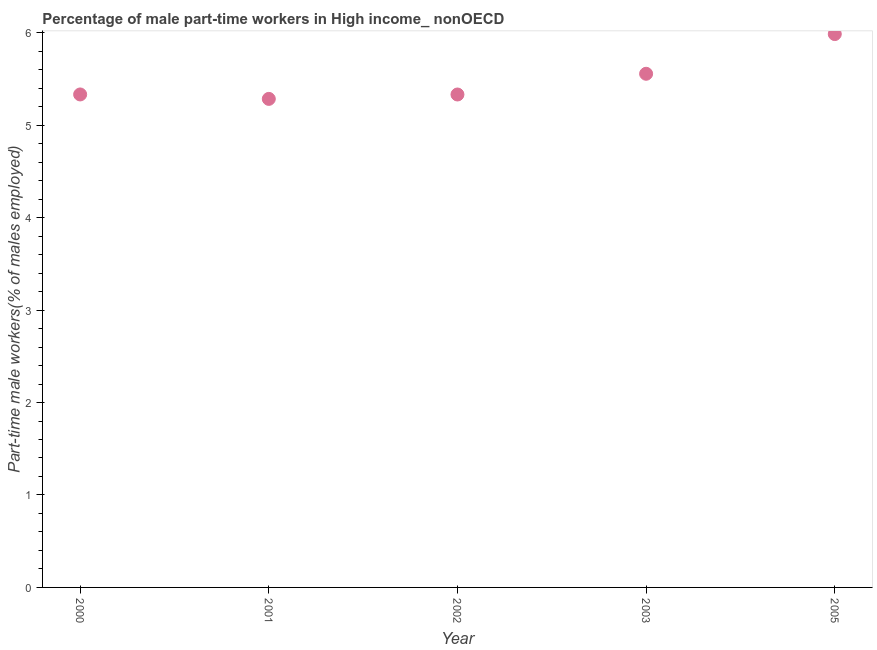What is the percentage of part-time male workers in 2005?
Give a very brief answer. 5.98. Across all years, what is the maximum percentage of part-time male workers?
Offer a very short reply. 5.98. Across all years, what is the minimum percentage of part-time male workers?
Your response must be concise. 5.28. In which year was the percentage of part-time male workers maximum?
Your answer should be very brief. 2005. What is the sum of the percentage of part-time male workers?
Provide a succinct answer. 27.49. What is the difference between the percentage of part-time male workers in 2002 and 2003?
Offer a terse response. -0.22. What is the average percentage of part-time male workers per year?
Ensure brevity in your answer.  5.5. What is the median percentage of part-time male workers?
Your response must be concise. 5.33. Do a majority of the years between 2000 and 2002 (inclusive) have percentage of part-time male workers greater than 1.8 %?
Keep it short and to the point. Yes. What is the ratio of the percentage of part-time male workers in 2000 to that in 2002?
Keep it short and to the point. 1. Is the percentage of part-time male workers in 2000 less than that in 2005?
Offer a terse response. Yes. What is the difference between the highest and the second highest percentage of part-time male workers?
Offer a terse response. 0.43. What is the difference between the highest and the lowest percentage of part-time male workers?
Your answer should be very brief. 0.7. Does the percentage of part-time male workers monotonically increase over the years?
Keep it short and to the point. No. How many years are there in the graph?
Offer a very short reply. 5. Does the graph contain grids?
Offer a terse response. No. What is the title of the graph?
Provide a succinct answer. Percentage of male part-time workers in High income_ nonOECD. What is the label or title of the Y-axis?
Give a very brief answer. Part-time male workers(% of males employed). What is the Part-time male workers(% of males employed) in 2000?
Provide a short and direct response. 5.33. What is the Part-time male workers(% of males employed) in 2001?
Provide a short and direct response. 5.28. What is the Part-time male workers(% of males employed) in 2002?
Offer a terse response. 5.33. What is the Part-time male workers(% of males employed) in 2003?
Provide a succinct answer. 5.56. What is the Part-time male workers(% of males employed) in 2005?
Ensure brevity in your answer.  5.98. What is the difference between the Part-time male workers(% of males employed) in 2000 and 2001?
Ensure brevity in your answer.  0.05. What is the difference between the Part-time male workers(% of males employed) in 2000 and 2002?
Provide a short and direct response. 0. What is the difference between the Part-time male workers(% of males employed) in 2000 and 2003?
Provide a succinct answer. -0.22. What is the difference between the Part-time male workers(% of males employed) in 2000 and 2005?
Offer a terse response. -0.65. What is the difference between the Part-time male workers(% of males employed) in 2001 and 2002?
Ensure brevity in your answer.  -0.05. What is the difference between the Part-time male workers(% of males employed) in 2001 and 2003?
Keep it short and to the point. -0.27. What is the difference between the Part-time male workers(% of males employed) in 2001 and 2005?
Your response must be concise. -0.7. What is the difference between the Part-time male workers(% of males employed) in 2002 and 2003?
Your response must be concise. -0.22. What is the difference between the Part-time male workers(% of males employed) in 2002 and 2005?
Your answer should be very brief. -0.65. What is the difference between the Part-time male workers(% of males employed) in 2003 and 2005?
Your answer should be compact. -0.43. What is the ratio of the Part-time male workers(% of males employed) in 2000 to that in 2001?
Keep it short and to the point. 1.01. What is the ratio of the Part-time male workers(% of males employed) in 2000 to that in 2005?
Your answer should be very brief. 0.89. What is the ratio of the Part-time male workers(% of males employed) in 2001 to that in 2003?
Your answer should be very brief. 0.95. What is the ratio of the Part-time male workers(% of males employed) in 2001 to that in 2005?
Give a very brief answer. 0.88. What is the ratio of the Part-time male workers(% of males employed) in 2002 to that in 2003?
Make the answer very short. 0.96. What is the ratio of the Part-time male workers(% of males employed) in 2002 to that in 2005?
Offer a very short reply. 0.89. What is the ratio of the Part-time male workers(% of males employed) in 2003 to that in 2005?
Your answer should be very brief. 0.93. 